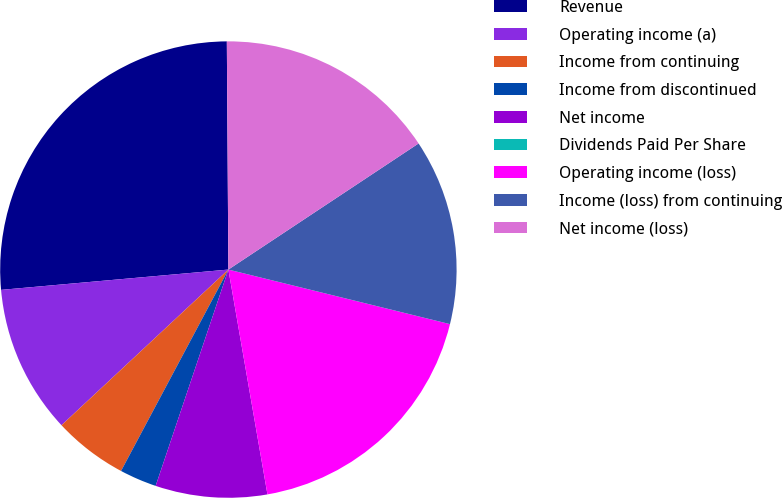Convert chart to OTSL. <chart><loc_0><loc_0><loc_500><loc_500><pie_chart><fcel>Revenue<fcel>Operating income (a)<fcel>Income from continuing<fcel>Income from discontinued<fcel>Net income<fcel>Dividends Paid Per Share<fcel>Operating income (loss)<fcel>Income (loss) from continuing<fcel>Net income (loss)<nl><fcel>26.31%<fcel>10.53%<fcel>5.26%<fcel>2.63%<fcel>7.9%<fcel>0.0%<fcel>18.42%<fcel>13.16%<fcel>15.79%<nl></chart> 